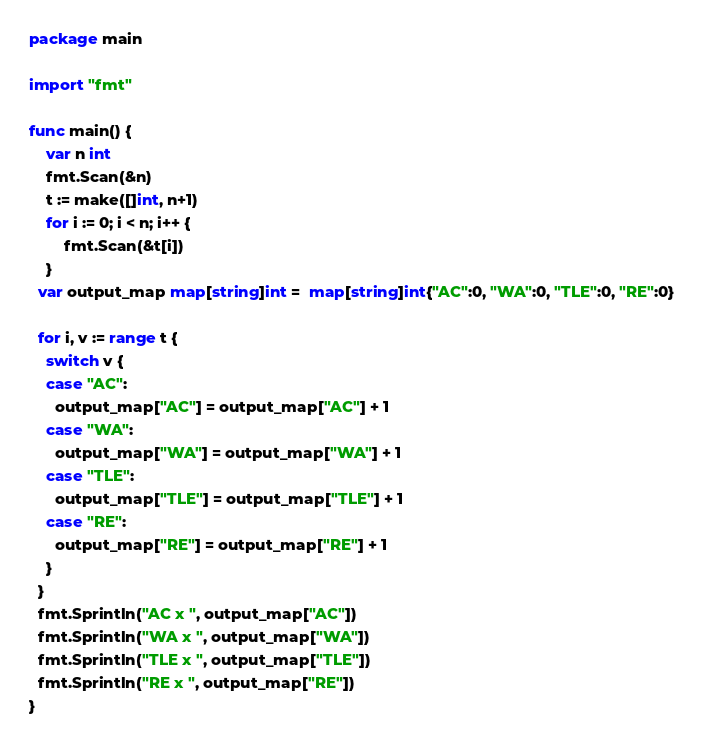<code> <loc_0><loc_0><loc_500><loc_500><_Go_>package main
 
import "fmt"
 
func main() {
	var n int
    fmt.Scan(&n)
   	t := make([]int, n+1)
    for i := 0; i < n; i++ {
        fmt.Scan(&t[i])
    }
  var output_map map[string]int =  map[string]int{"AC":0, "WA":0, "TLE":0, "RE":0}
  
  for i, v := range t {
    switch v {
    case "AC":
      output_map["AC"] = output_map["AC"] + 1
    case "WA":
      output_map["WA"] = output_map["WA"] + 1
    case "TLE":
      output_map["TLE"] = output_map["TLE"] + 1
    case "RE":
      output_map["RE"] = output_map["RE"] + 1
    }
  }
  fmt.Sprintln("AC x ", output_map["AC"])
  fmt.Sprintln("WA x ", output_map["WA"])
  fmt.Sprintln("TLE x ", output_map["TLE"])
  fmt.Sprintln("RE x ", output_map["RE"])
}
</code> 